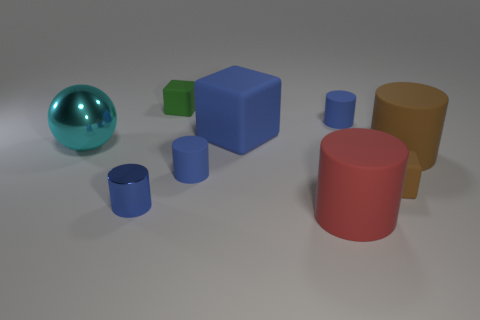Subtract all large rubber cubes. How many cubes are left? 2 Subtract all green blocks. How many blocks are left? 2 Subtract all blocks. How many objects are left? 6 Subtract all blue cylinders. How many yellow cubes are left? 0 Subtract all large yellow shiny cubes. Subtract all large brown objects. How many objects are left? 8 Add 2 shiny spheres. How many shiny spheres are left? 3 Add 4 rubber cylinders. How many rubber cylinders exist? 8 Add 1 metal things. How many objects exist? 10 Subtract 1 cyan balls. How many objects are left? 8 Subtract 4 cylinders. How many cylinders are left? 1 